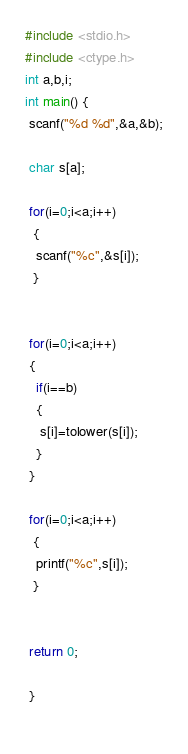Convert code to text. <code><loc_0><loc_0><loc_500><loc_500><_C_>#include <stdio.h>
#include <ctype.h>
int a,b,i;
int main() {
 scanf("%d %d",&a,&b);
 
 char s[a];
 
 for(i=0;i<a;i++)
  {
   scanf("%c",&s[i]);
  }
 
  
 for(i=0;i<a;i++)
 {
   if(i==b)
   {
    s[i]=tolower(s[i]);
   }
 }
 
 for(i=0;i<a;i++)
  {
   printf("%c",s[i]); 
  }
 

 return 0;
 
 } 
  </code> 